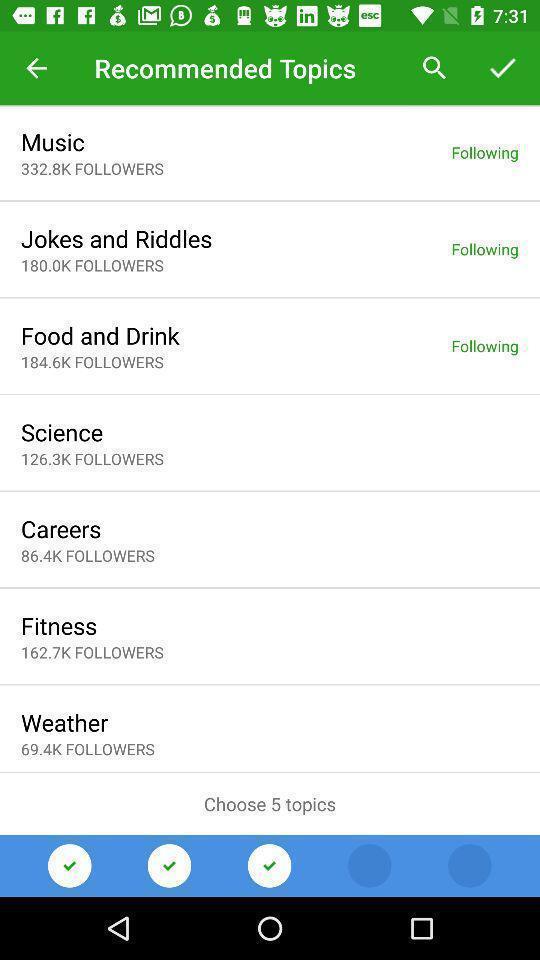Describe the visual elements of this screenshot. Page displaying with list of recommended topics. 